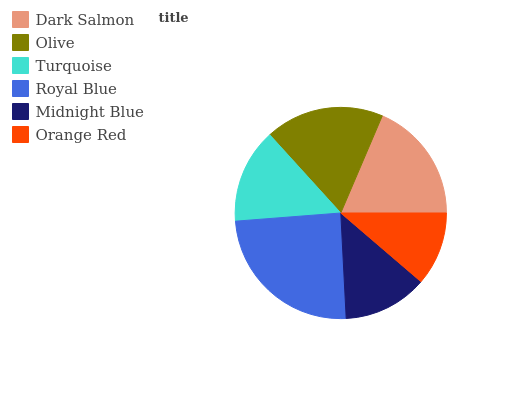Is Orange Red the minimum?
Answer yes or no. Yes. Is Royal Blue the maximum?
Answer yes or no. Yes. Is Olive the minimum?
Answer yes or no. No. Is Olive the maximum?
Answer yes or no. No. Is Dark Salmon greater than Olive?
Answer yes or no. Yes. Is Olive less than Dark Salmon?
Answer yes or no. Yes. Is Olive greater than Dark Salmon?
Answer yes or no. No. Is Dark Salmon less than Olive?
Answer yes or no. No. Is Olive the high median?
Answer yes or no. Yes. Is Turquoise the low median?
Answer yes or no. Yes. Is Royal Blue the high median?
Answer yes or no. No. Is Olive the low median?
Answer yes or no. No. 